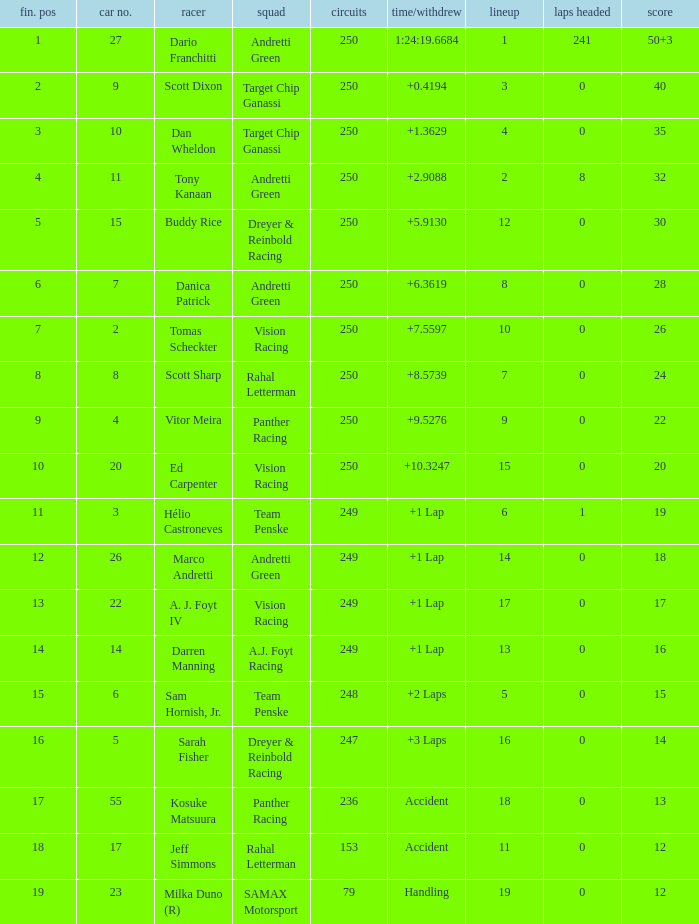For 12 accident points, what is the total count of finite positions? 1.0. 